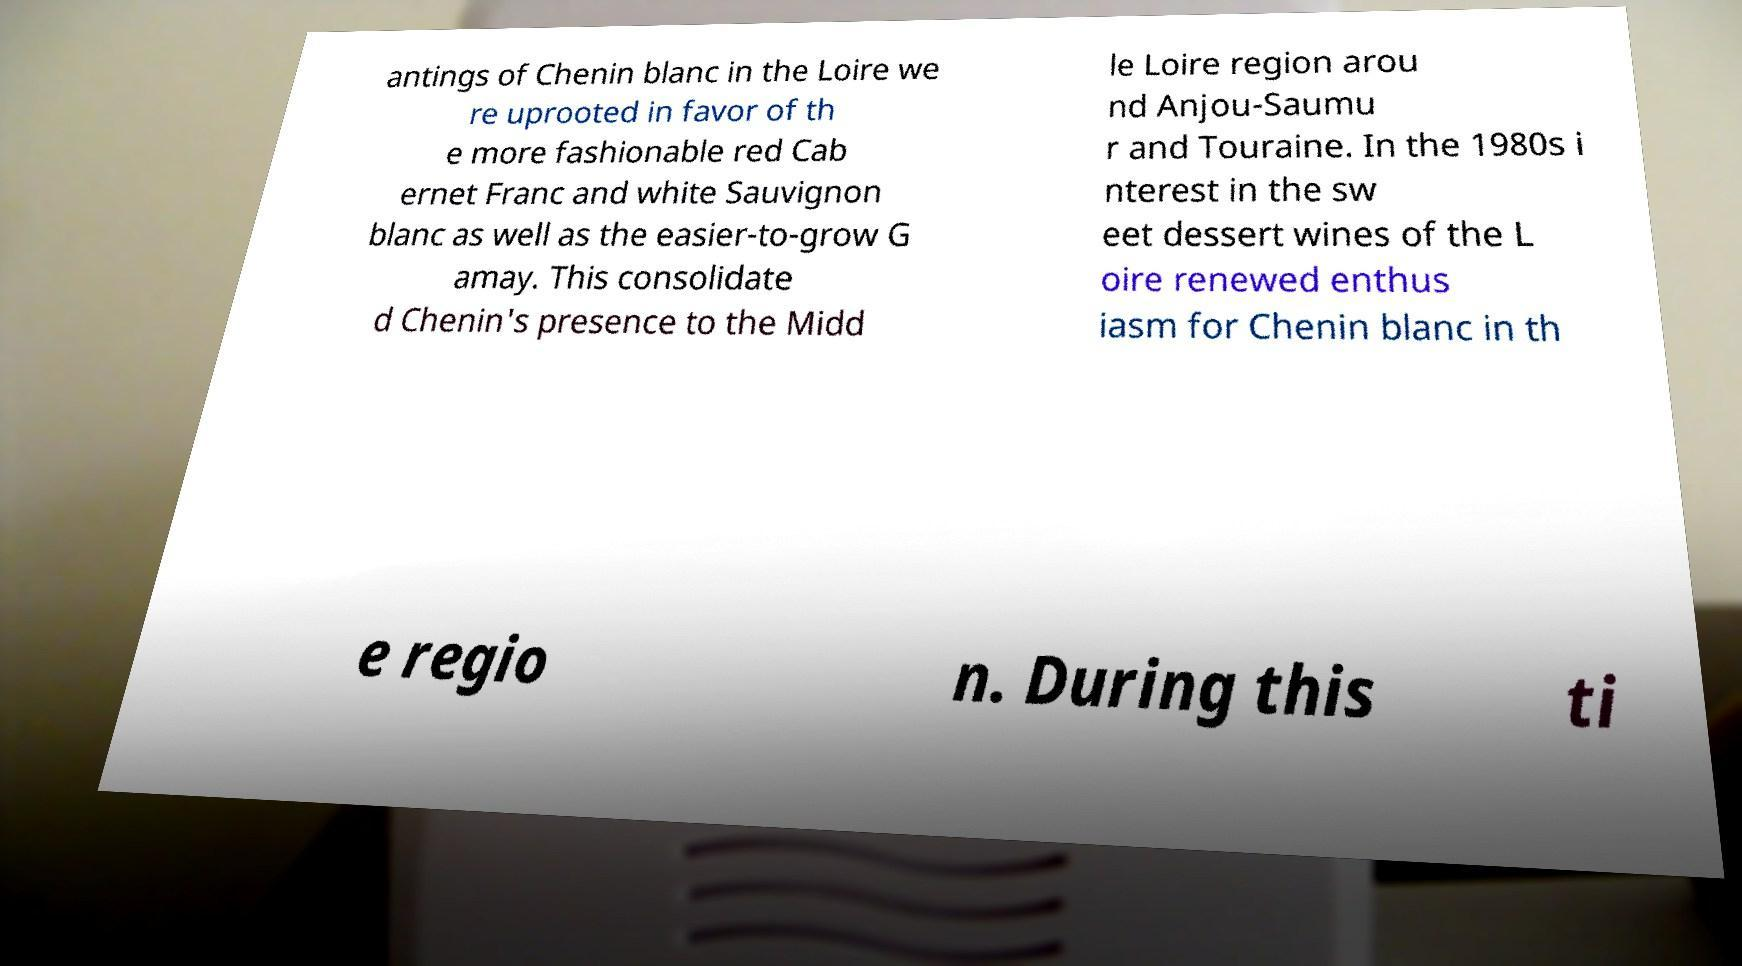Can you accurately transcribe the text from the provided image for me? antings of Chenin blanc in the Loire we re uprooted in favor of th e more fashionable red Cab ernet Franc and white Sauvignon blanc as well as the easier-to-grow G amay. This consolidate d Chenin's presence to the Midd le Loire region arou nd Anjou-Saumu r and Touraine. In the 1980s i nterest in the sw eet dessert wines of the L oire renewed enthus iasm for Chenin blanc in th e regio n. During this ti 